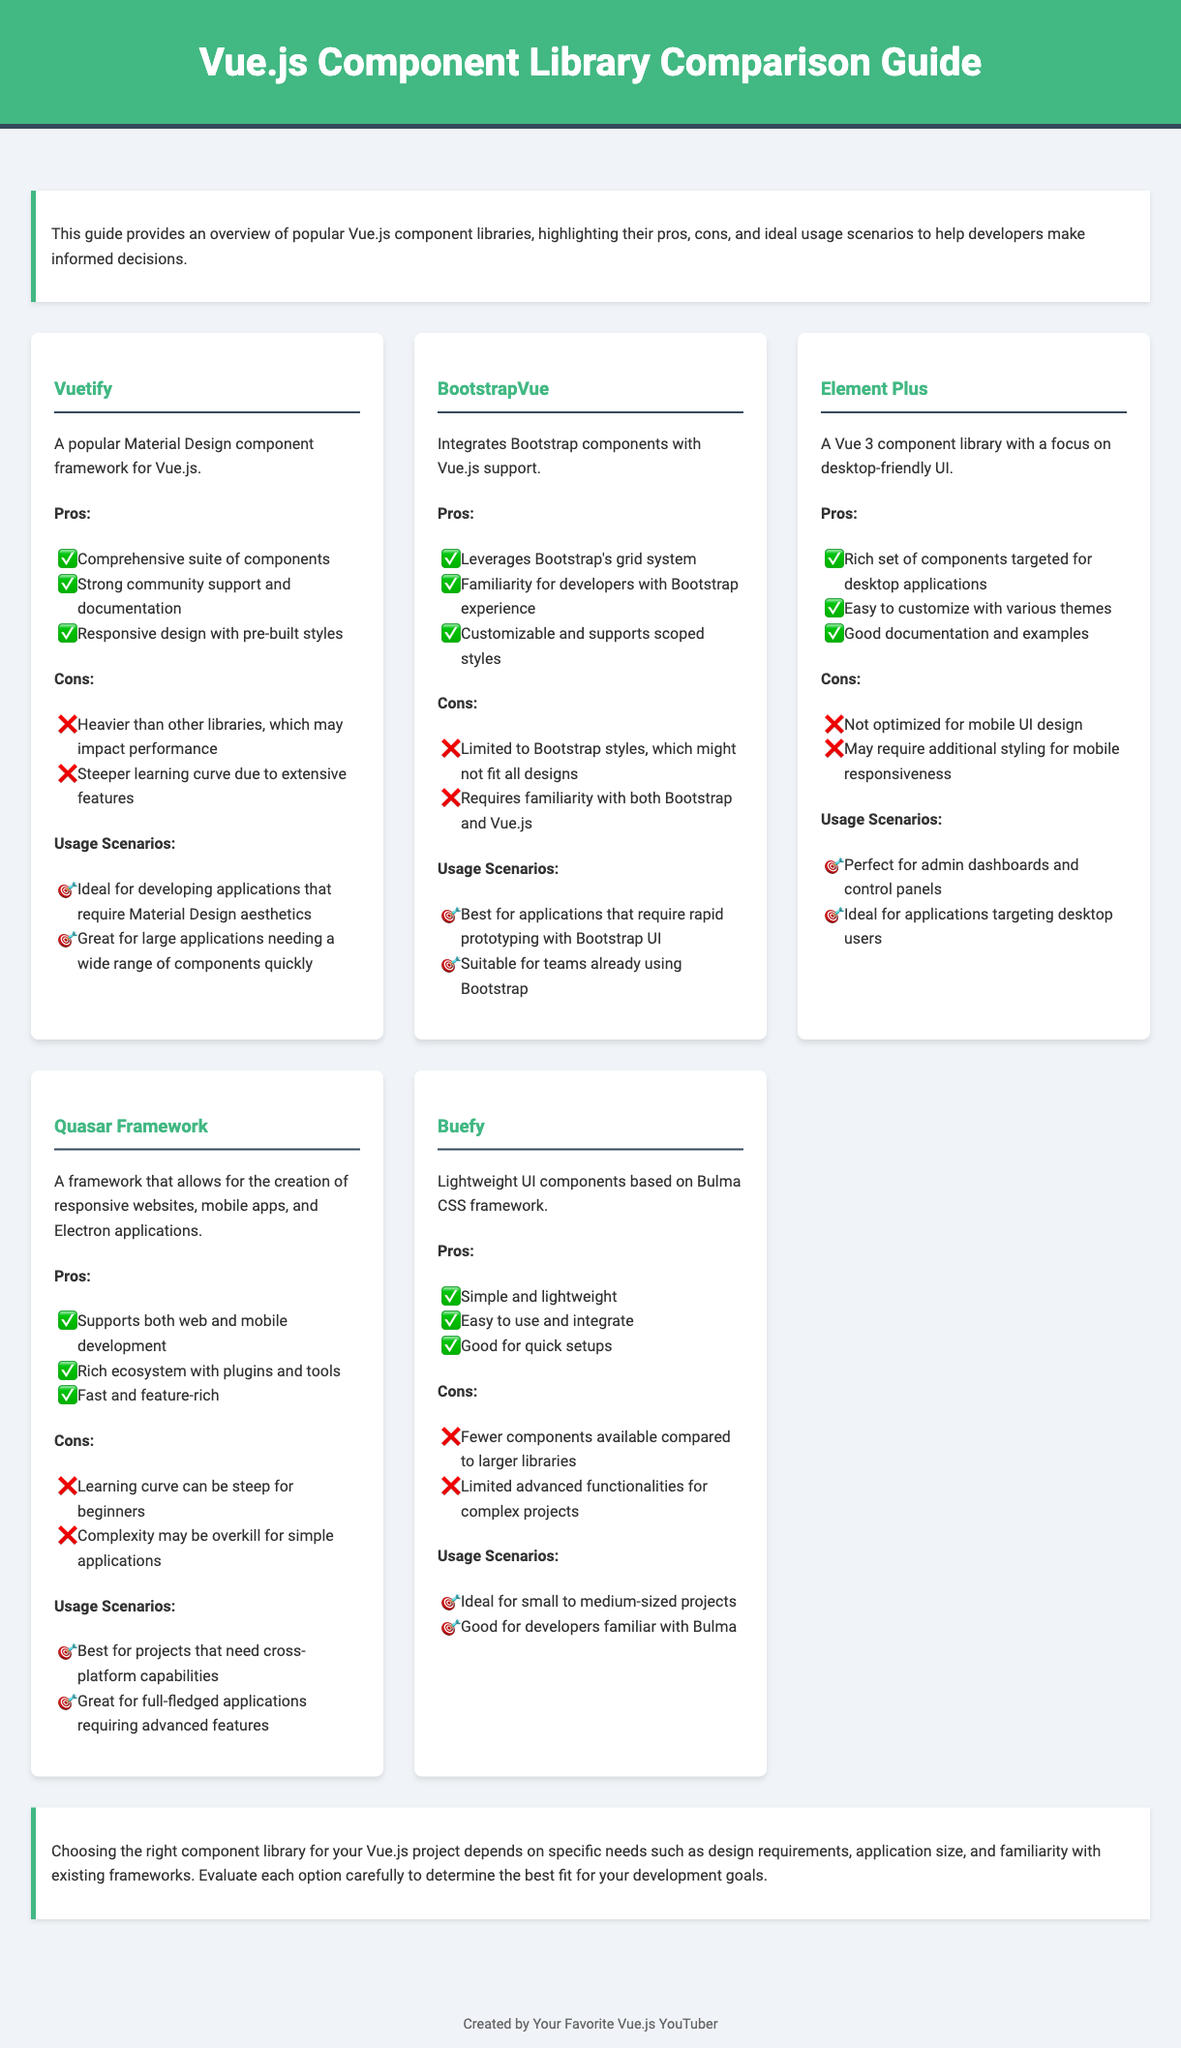What is the title of the document? The title is provided in the header of the document, which states "Vue.js Component Library Comparison Guide."
Answer: Vue.js Component Library Comparison Guide How many libraries are compared in the document? The document lists a total of five Vue.js component libraries.
Answer: Five What is a pro of Vuetify? The pros of Vuetify include several points, one of which is "Comprehensive suite of components."
Answer: Comprehensive suite of components Which library is described as lightweight and based on Bulma? The library's description indicates that it is "Lightweight UI components based on Bulma CSS framework."
Answer: Buefy What type of applications is Element Plus ideal for? The document specifies that Element Plus is "Ideal for applications targeting desktop users."
Answer: Desktop users What is a common con of using Quasar Framework? One of the cons listed is "Learning curve can be steep for beginners."
Answer: Learning curve can be steep for beginners Which library integrates Bootstrap components? The document describes BootstrapVue as integrating Bootstrap components with Vue.js support.
Answer: BootstrapVue For what kind of projects is Buefy best suited? The document suggests Buefy is "Ideal for small to medium-sized projects."
Answer: Small to medium-sized projects 